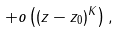Convert formula to latex. <formula><loc_0><loc_0><loc_500><loc_500>+ o \left ( ( z - z _ { 0 } ) ^ { K } \right ) ,</formula> 